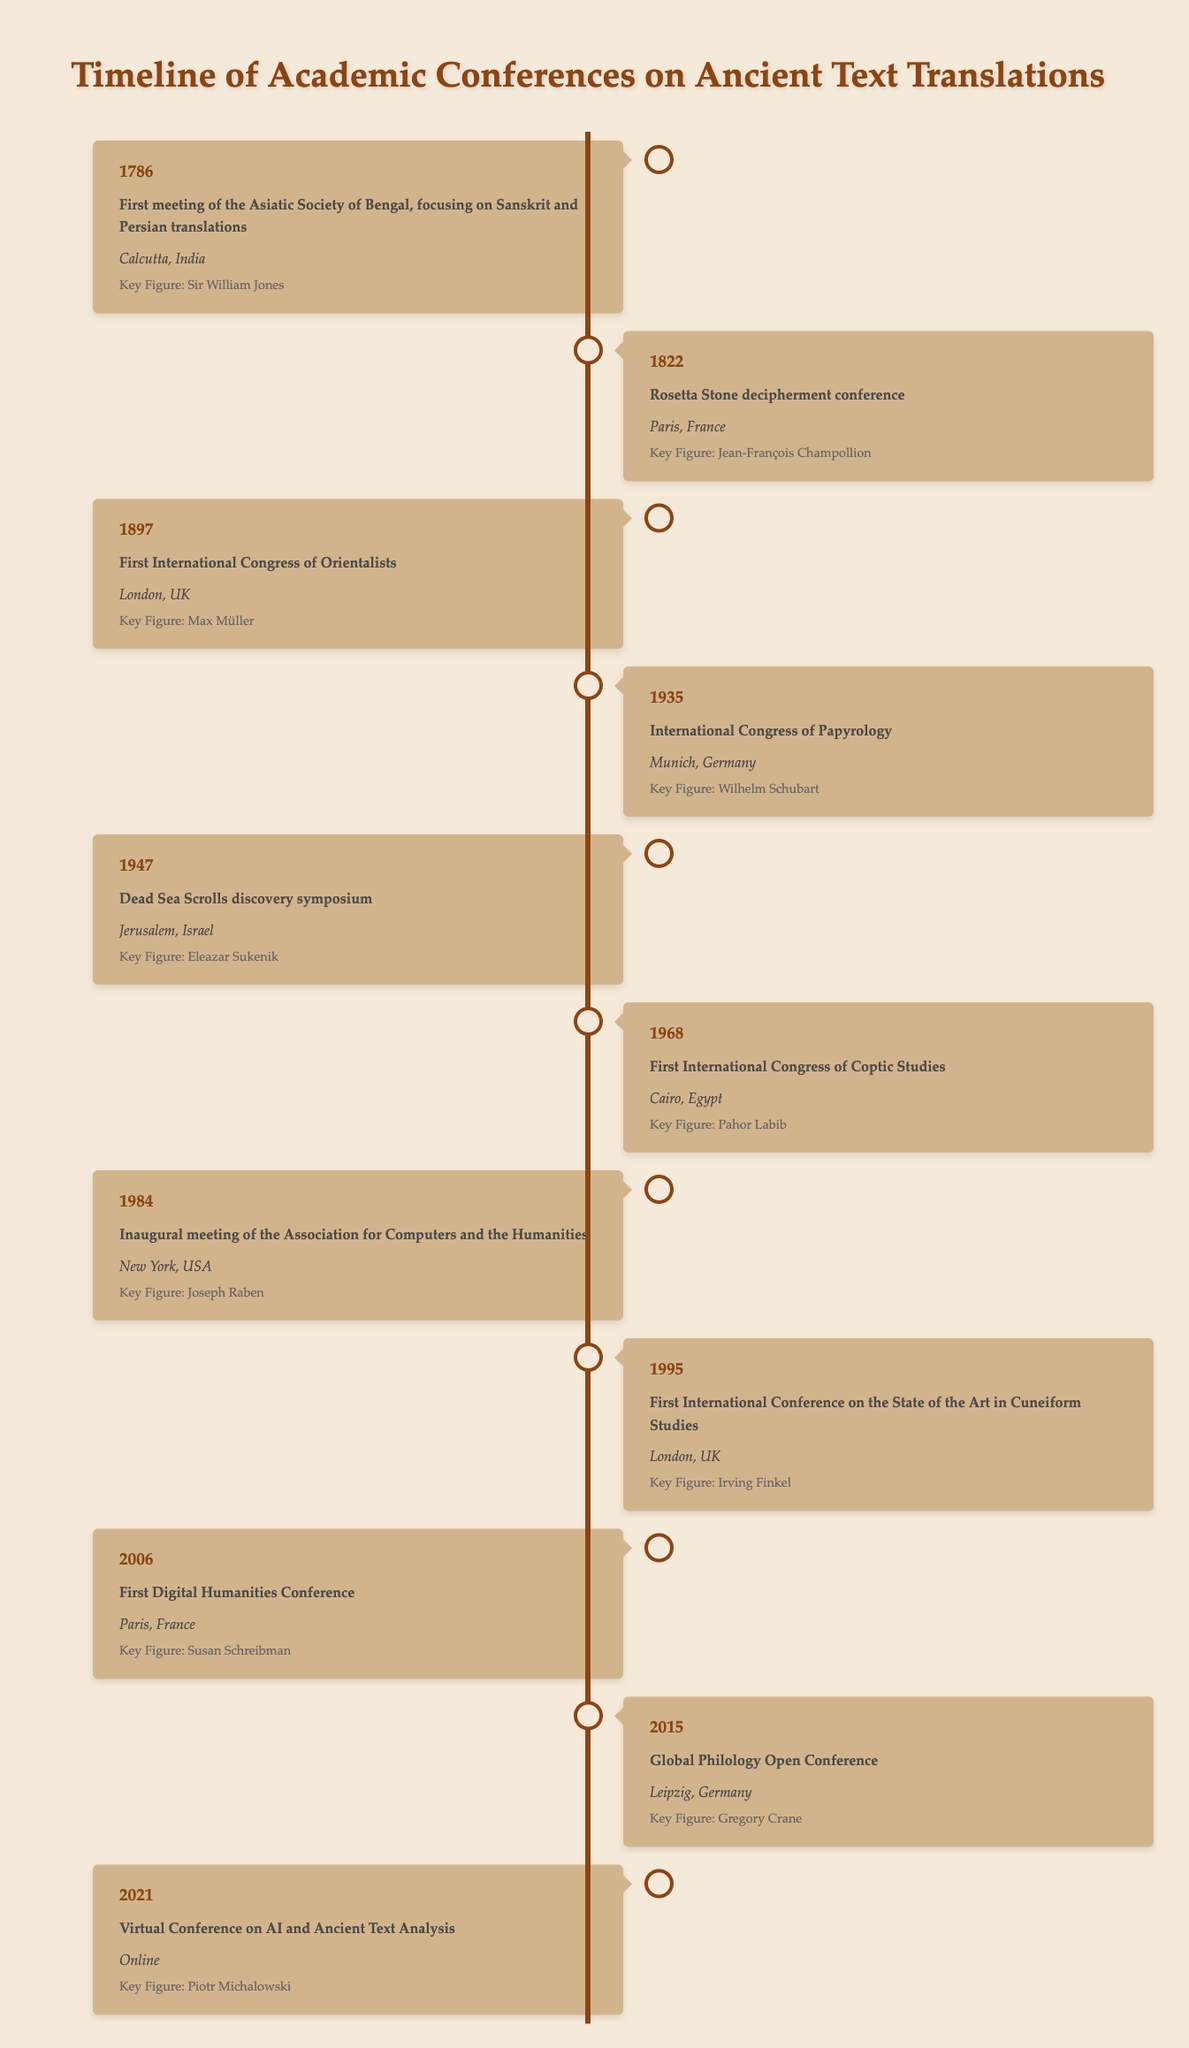What year did the First International Congress of Orientalists take place? The event listed in the table as "First International Congress of Orientalists" indicates that it occurred in the year 1897.
Answer: 1897 Which location hosted the Dead Sea Scrolls discovery symposium? The entry for the event "Dead Sea Scrolls discovery symposium" specifies that it took place in Jerusalem, Israel.
Answer: Jerusalem, Israel Is the key figure for the Rosetta Stone decipherment conference Sir William Jones? The table shows that the key figure for the Rosetta Stone decipherment conference is Jean-François Champollion, not Sir William Jones. Therefore, the statement is false.
Answer: No How many years passed between the first meeting of the Asiatic Society of Bengal and the first International Congress of Coptic Studies? The first meeting of the Asiatic Society of Bengal was in 1786 and the first International Congress of Coptic Studies was in 1968. Calculating the difference: 1968 - 1786 = 182 years.
Answer: 182 Which event occurred in Paris, France? The table displays two events in Paris: the "Rosetta Stone decipherment conference" in 1822 and the "First Digital Humanities Conference" in 2006.
Answer: Two events: Rosetta Stone decipherment conference, First Digital Humanities Conference Basing on the timeline, was there a conference focusing on ancient texts before the 20th century? The earliest event in the timeline is from 1786, when the First meeting of the Asiatic Society of Bengal occurred, focusing on ancient translations, indicating that such a conference did take place before the 20th century.
Answer: Yes What is the average year of all events listed in the timeline? To find the average year, we sum up all the years of events listed (1786 + 1822 + 1897 + 1935 + 1947 + 1968 + 1984 + 1995 + 2006 + 2015 + 2021 = 1996). There are 11 events, so the average year is 1996 / 11 = 181.45 or approximately 1819.
Answer: 1996 Who was the key figure at the First Digital Humanities Conference? According to the event entry, the key figure at the First Digital Humanities Conference, held in 2006 in Paris, France, was Susan Schreibman.
Answer: Susan Schreibman 